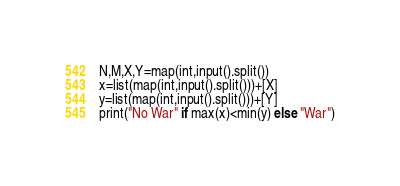Convert code to text. <code><loc_0><loc_0><loc_500><loc_500><_Python_>N,M,X,Y=map(int,input().split())
x=list(map(int,input().split()))+[X]
y=list(map(int,input().split()))+[Y]
print("No War" if max(x)<min(y) else "War")</code> 